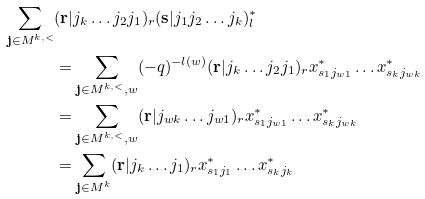Convert formula to latex. <formula><loc_0><loc_0><loc_500><loc_500>\sum _ { \mathbf j \in M ^ { k , < } } & ( \mathbf r | j _ { k } \dots j _ { 2 } j _ { 1 } ) _ { r } ( \mathbf s | j _ { 1 } j _ { 2 } \dots j _ { k } ) _ { l } ^ { * } \\ & = \sum _ { \mathbf j \in M ^ { k , < } , w } ( - q ) ^ { - l ( w ) } ( \mathbf r | j _ { k } \dots j _ { 2 } j _ { 1 } ) _ { r } x _ { s _ { 1 } j _ { w 1 } } ^ { * } \dots x _ { s _ { k } j _ { w k } } ^ { * } \\ & = \sum _ { \mathbf j \in M ^ { k , < } , w } ( \mathbf r | j _ { w k } \dots j _ { w 1 } ) _ { r } x _ { s _ { 1 } j _ { w 1 } } ^ { * } \dots x _ { s _ { k } j _ { w k } } ^ { * } \\ & = \sum _ { \mathbf j \in M ^ { k } } ( \mathbf r | j _ { k } \dots j _ { 1 } ) _ { r } x _ { s _ { 1 } j _ { 1 } } ^ { * } \dots x _ { s _ { k } j _ { k } } ^ { * }</formula> 